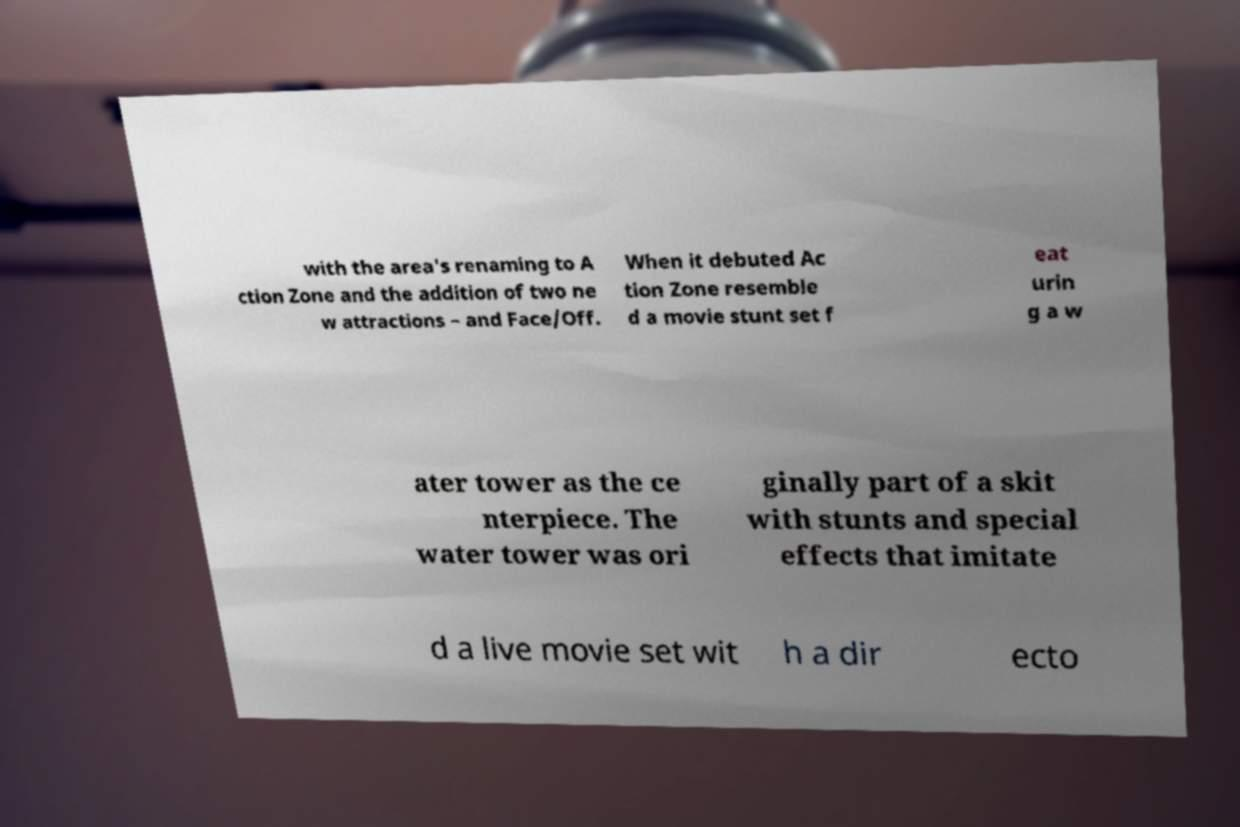Can you read and provide the text displayed in the image?This photo seems to have some interesting text. Can you extract and type it out for me? with the area's renaming to A ction Zone and the addition of two ne w attractions – and Face/Off. When it debuted Ac tion Zone resemble d a movie stunt set f eat urin g a w ater tower as the ce nterpiece. The water tower was ori ginally part of a skit with stunts and special effects that imitate d a live movie set wit h a dir ecto 